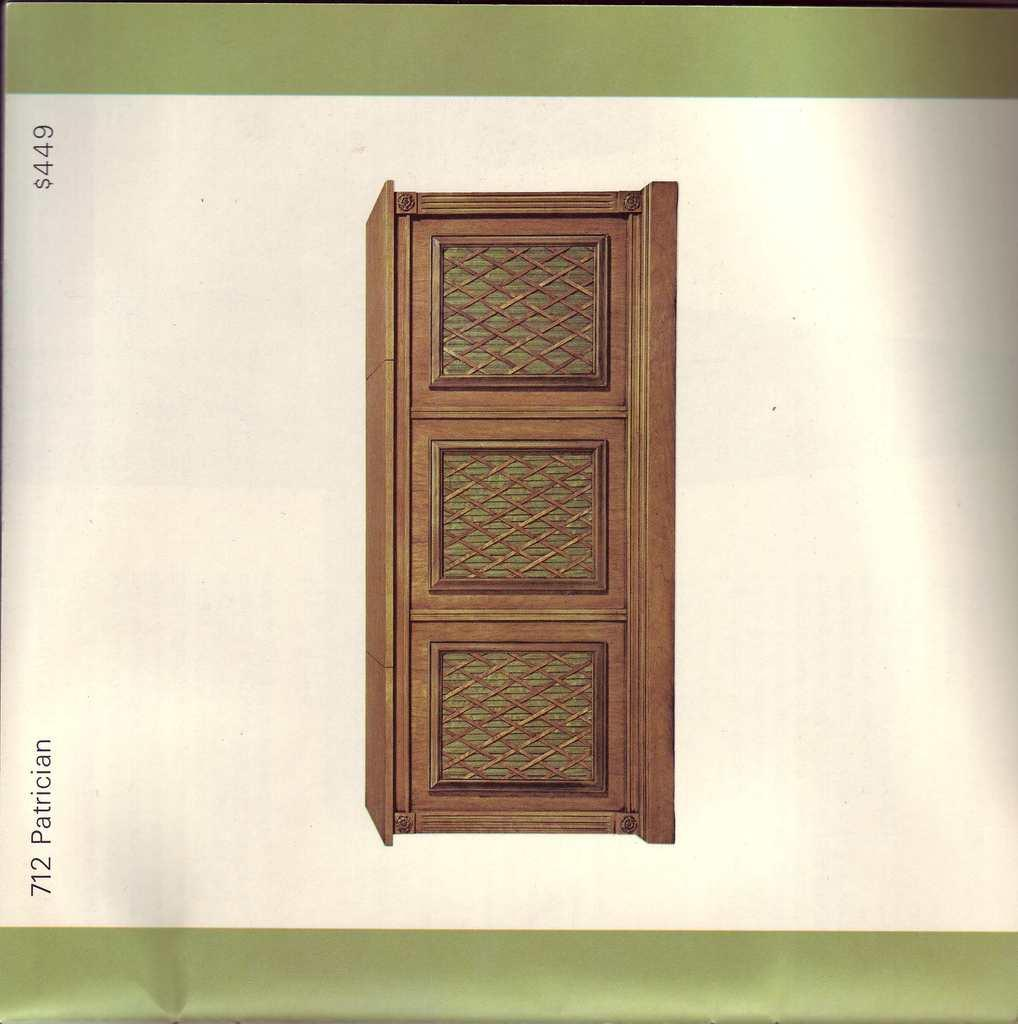What are the colors of the objects in the image? There is a green and white colored thing and a brown colored thing in the image. Can you describe the writing in the image? There is writing at a few places in the image. How many people are smiling in the image? There are no people present in the image, so it is not possible to determine how many people might be smiling. 